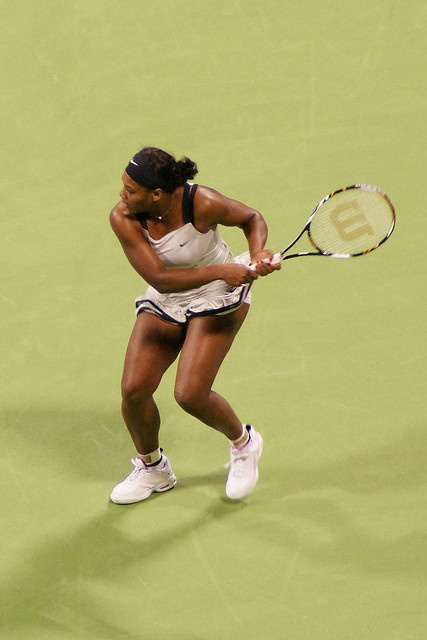Describe the objects in this image and their specific colors. I can see people in khaki, maroon, black, brown, and salmon tones and tennis racket in khaki and tan tones in this image. 